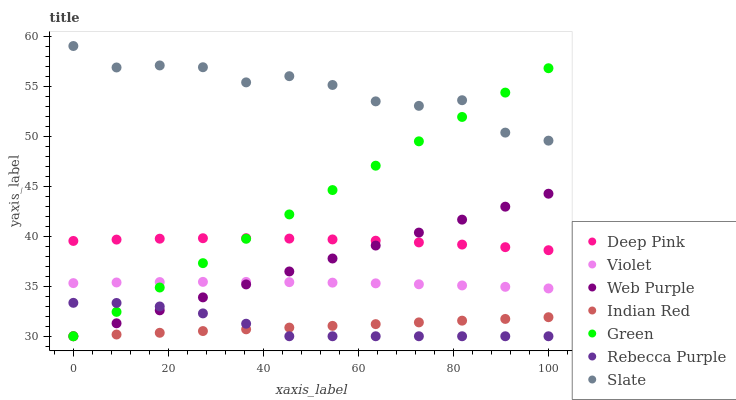Does Indian Red have the minimum area under the curve?
Answer yes or no. Yes. Does Slate have the maximum area under the curve?
Answer yes or no. Yes. Does Web Purple have the minimum area under the curve?
Answer yes or no. No. Does Web Purple have the maximum area under the curve?
Answer yes or no. No. Is Indian Red the smoothest?
Answer yes or no. Yes. Is Slate the roughest?
Answer yes or no. Yes. Is Web Purple the smoothest?
Answer yes or no. No. Is Web Purple the roughest?
Answer yes or no. No. Does Web Purple have the lowest value?
Answer yes or no. Yes. Does Slate have the lowest value?
Answer yes or no. No. Does Slate have the highest value?
Answer yes or no. Yes. Does Web Purple have the highest value?
Answer yes or no. No. Is Rebecca Purple less than Deep Pink?
Answer yes or no. Yes. Is Slate greater than Indian Red?
Answer yes or no. Yes. Does Web Purple intersect Green?
Answer yes or no. Yes. Is Web Purple less than Green?
Answer yes or no. No. Is Web Purple greater than Green?
Answer yes or no. No. Does Rebecca Purple intersect Deep Pink?
Answer yes or no. No. 